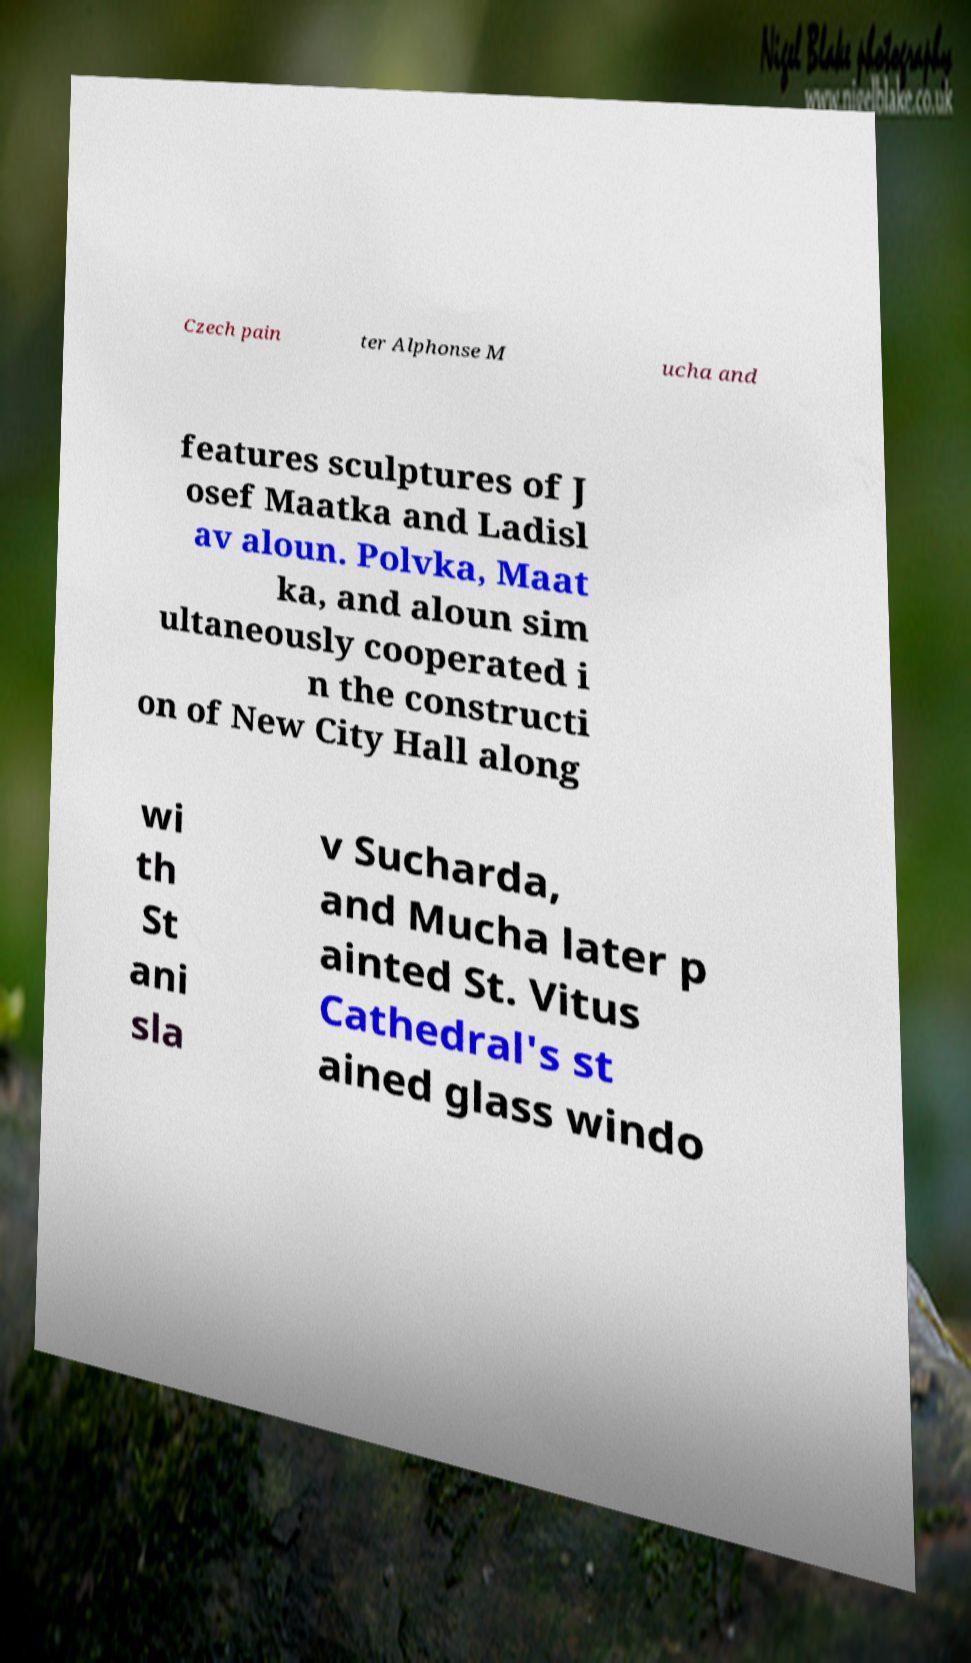Can you read and provide the text displayed in the image?This photo seems to have some interesting text. Can you extract and type it out for me? Czech pain ter Alphonse M ucha and features sculptures of J osef Maatka and Ladisl av aloun. Polvka, Maat ka, and aloun sim ultaneously cooperated i n the constructi on of New City Hall along wi th St ani sla v Sucharda, and Mucha later p ainted St. Vitus Cathedral's st ained glass windo 